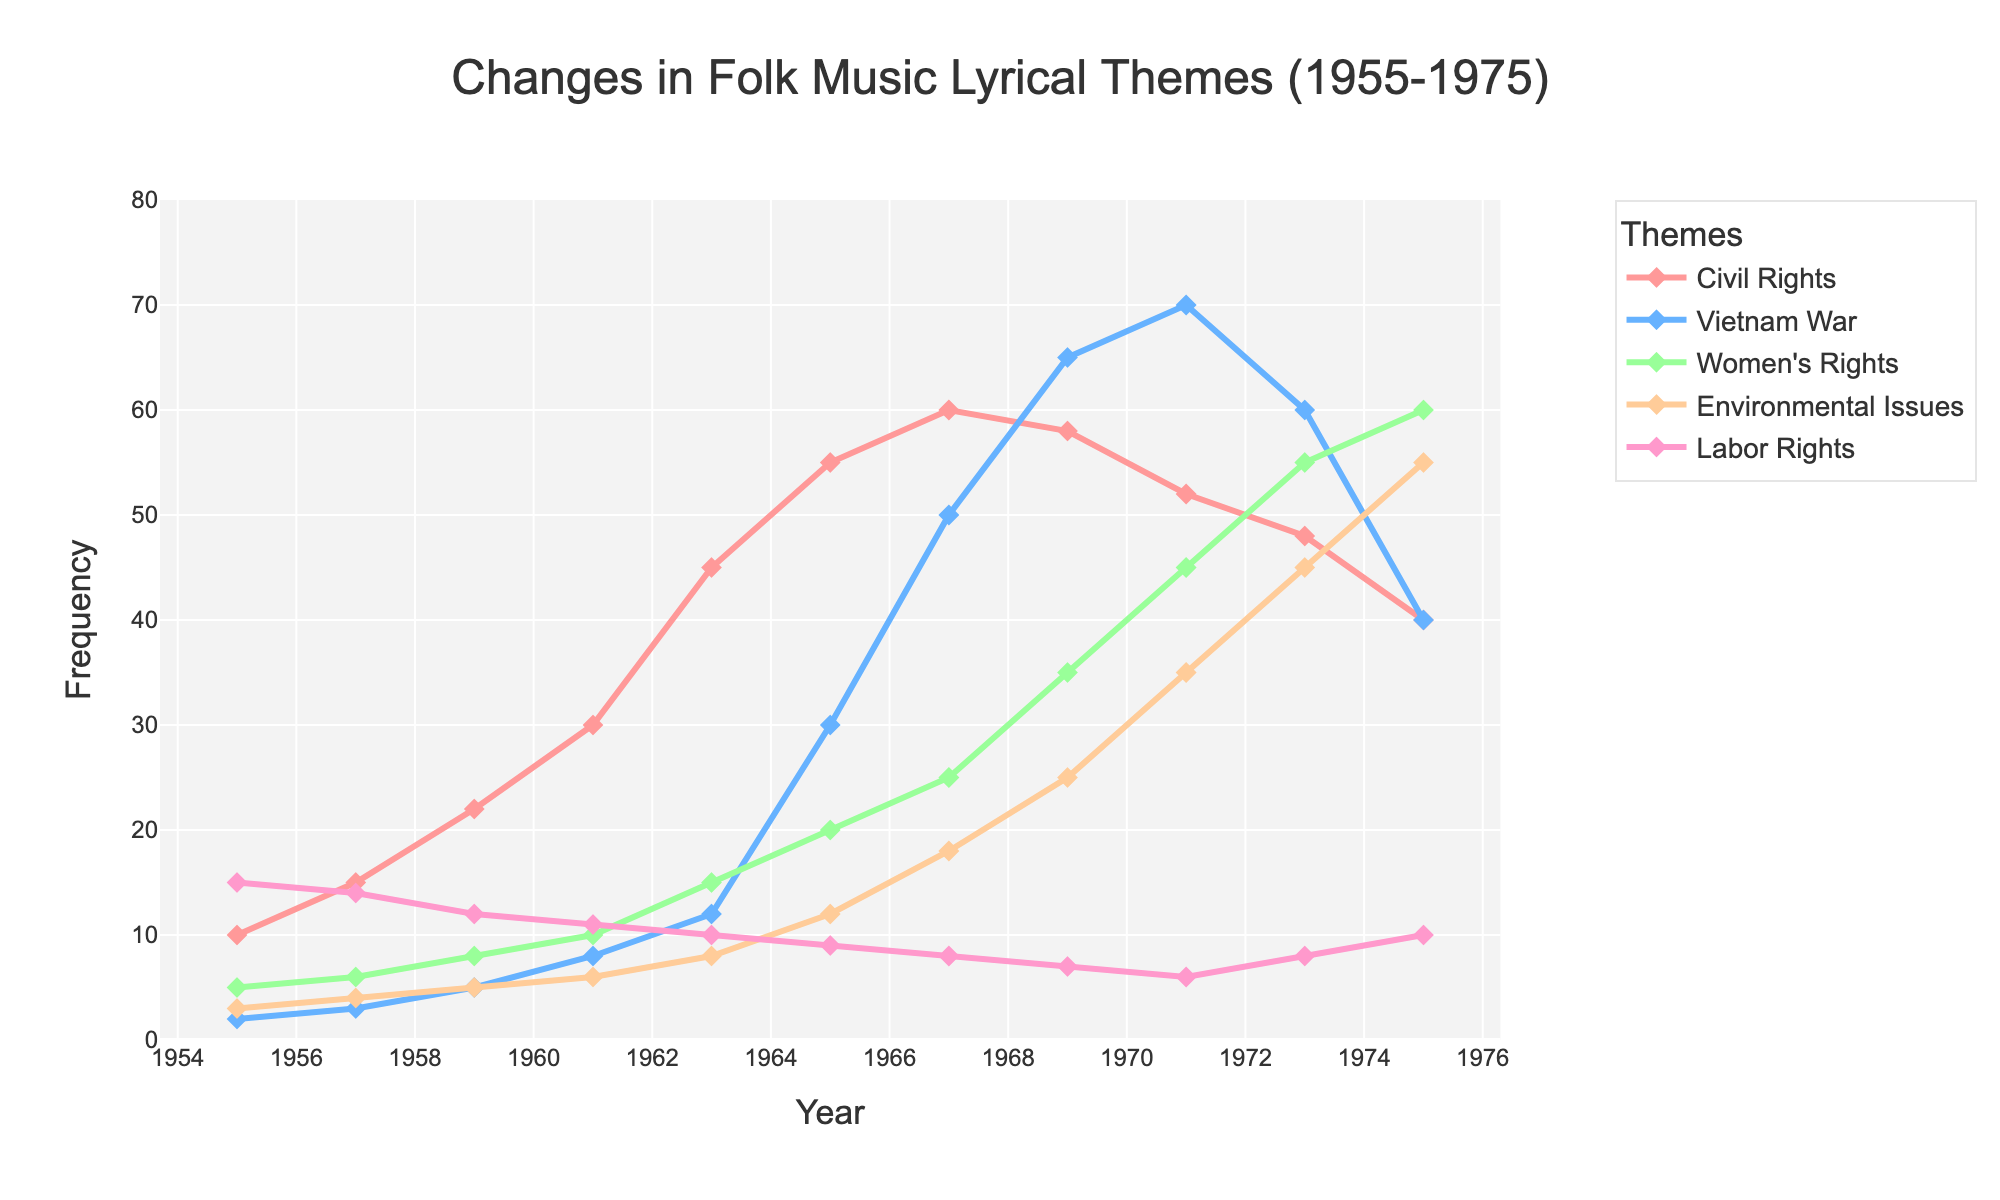What social issue theme saw the largest increase in mentions from 1955 to 1975? To determine which theme had the largest increase, we subtract the 1955 values from the 1975 values for each theme: Civil Rights (40 - 10 = 30), Vietnam War (40 - 2 = 38), Women's Rights (60 - 5 = 55), Environmental Issues (55 - 3 = 52), Labor Rights (10 - 15 = -5). Women's Rights saw the largest increase with an increase of 55 mentions.
Answer: Women's Rights Between which consecutive years did the Vietnam War theme see the largest increase? We calculate the differences between consecutive years: 1955-1957 (3 - 2 = 1), 1957-1959 (5 - 3 = 2), 1959-1961 (8 - 5 = 3), 1961-1963 (12 - 8 = 4), 1963-1965 (30 - 12 = 18), 1965-1967 (50 - 30 = 20), 1967-1969 (65 - 50 = 15), 1969-1971 (70 - 65 = 5), 1971-1973 (60 - 70 = -10), 1973-1975 (40 - 60 = -20). The largest increase was between 1965 and 1967 with an increase of 20 mentions.
Answer: 1965 and 1967 What was the total frequency of all themes in 1967? Summing up the values in 1967: 60 (Civil Rights) + 50 (Vietnam War) + 25 (Women's Rights) + 18 (Environmental Issues) + 8 (Labor Rights) = 161 mentions.
Answer: 161 In what year did Environmental Issues first surpass Women's Rights in mentions? Comparing the yearly mentions, Environmental Issues first surpass Women's Rights in 1973 (Environmental Issues 45, Women's Rights 35). Before 1973, Women's Rights were consistently higher.
Answer: 1973 Which theme had the highest peak value over the entire period (1955-1975), and what was that value? Observing the peak values: Civil Rights peaked at 60 in 1967, Vietnam War at 70 in 1971, Women's Rights at 60 in 1975, Environmental Issues at 55 in 1975, and Labor Rights at 15 in 1955. The highest value was Vietnam War with 70 mentions in 1971.
Answer: Vietnam War, 70 What is the overall trend of mentions related to Labor Rights from 1955 to 1975? Looking at the data for Labor Rights: 1955 (15), 1957 (14), 1959 (12), 1961 (11), 1963 (10), 1965 (9), 1967 (8), 1969 (7), 1971 (6), 1973 (8), 1975 (10). The trend shows a general decline from 1955 to 1971, but a slight increase again after 1971.
Answer: General decline, slight increase after 1971 